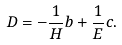Convert formula to latex. <formula><loc_0><loc_0><loc_500><loc_500>D = - \frac { 1 } { H } b + \frac { 1 } { E } c .</formula> 